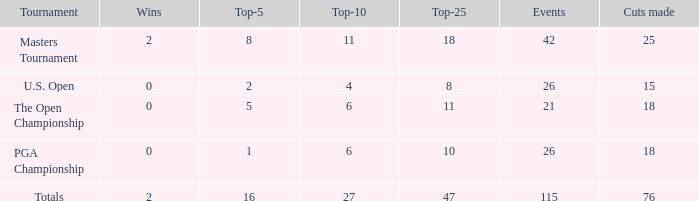What are the largest cuts made when the events are less than 21? None. 